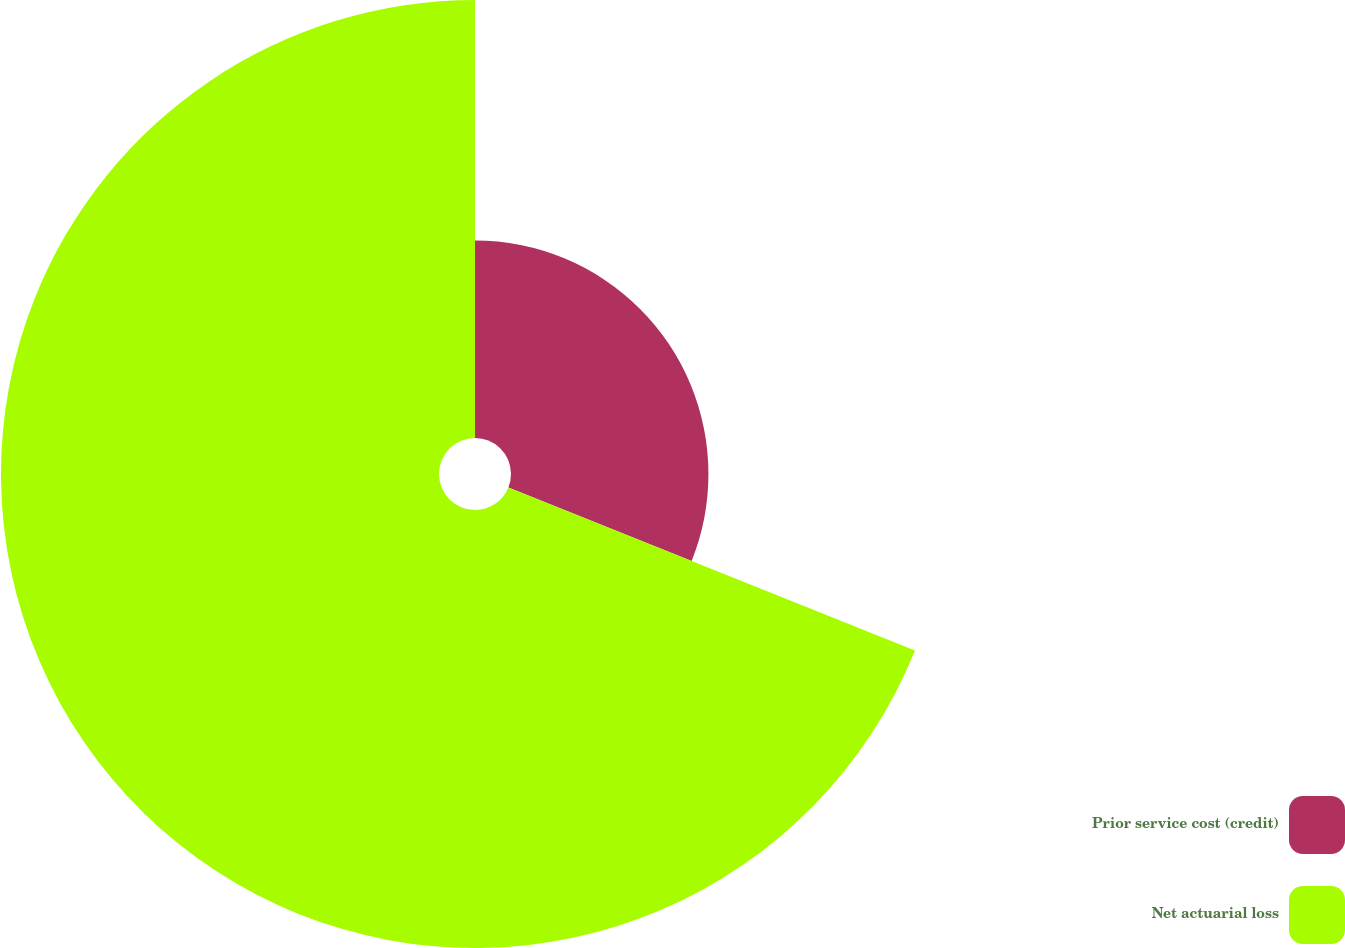Convert chart. <chart><loc_0><loc_0><loc_500><loc_500><pie_chart><fcel>Prior service cost (credit)<fcel>Net actuarial loss<nl><fcel>31.07%<fcel>68.93%<nl></chart> 